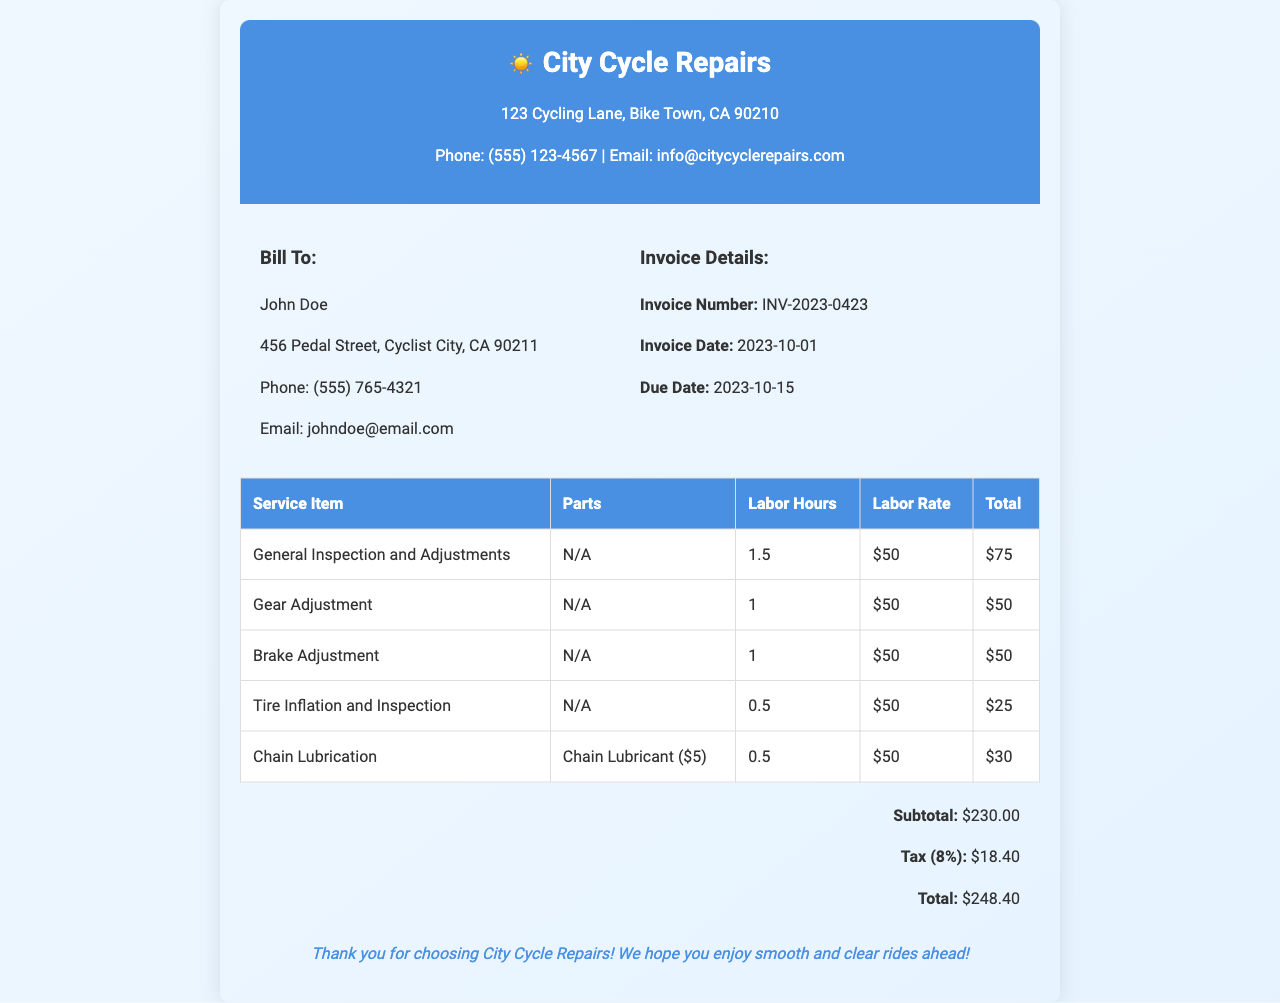What is the invoice number? The invoice number is a specific identifier for the invoice, found in the invoice details section.
Answer: INV-2023-0423 What is the due date? The due date indicates the deadline for payment on the invoice, which is specified in the invoice details.
Answer: 2023-10-15 How much was charged for chain lubrication? The charge for chain lubrication is listed under the service items total.
Answer: $30 What is the subtotal before tax? The subtotal is the total cost of services and parts before applying tax, mentioned in the summary section.
Answer: $230.00 What is the tax percentage applied? The document specifies the tax percentage that is applied to the subtotal.
Answer: 8% What is the total amount due? The total amount due represents the final amount payable on the invoice, calculated after tax is applied.
Answer: $248.40 How many hours were billed for the general inspection and adjustments? The number of labor hours for the general inspection and adjustments is specified under the service items.
Answer: 1.5 What is the phone number for City Cycle Repairs? The phone number for City Cycle Repairs is provided in the contact information at the top.
Answer: (555) 123-4567 What is the service included for tire inflation? The service detailed for tire inflation is listed alongside its charges in the table of services provided.
Answer: Tire Inflation and Inspection 